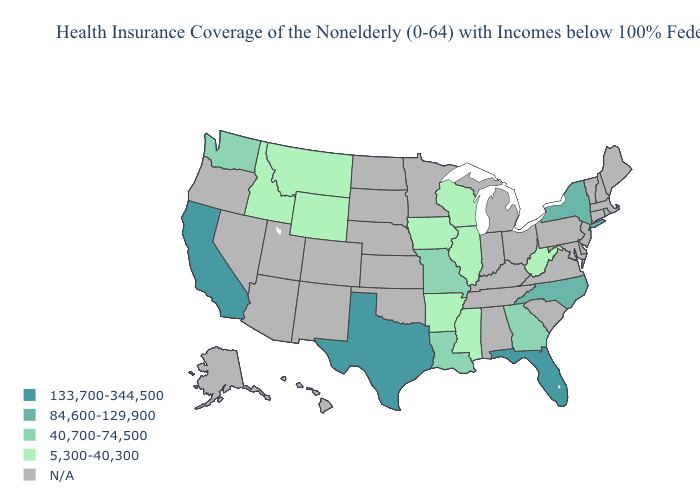What is the lowest value in the USA?
Keep it brief. 5,300-40,300. What is the value of Alaska?
Quick response, please. N/A. Name the states that have a value in the range 133,700-344,500?
Keep it brief. California, Florida, Texas. Which states hav the highest value in the Northeast?
Concise answer only. New York. What is the value of Alaska?
Quick response, please. N/A. Does West Virginia have the lowest value in the USA?
Keep it brief. Yes. What is the value of Alabama?
Write a very short answer. N/A. Name the states that have a value in the range 133,700-344,500?
Give a very brief answer. California, Florida, Texas. Which states have the lowest value in the Northeast?
Answer briefly. New York. Which states hav the highest value in the South?
Be succinct. Florida, Texas. What is the value of Oregon?
Quick response, please. N/A. 